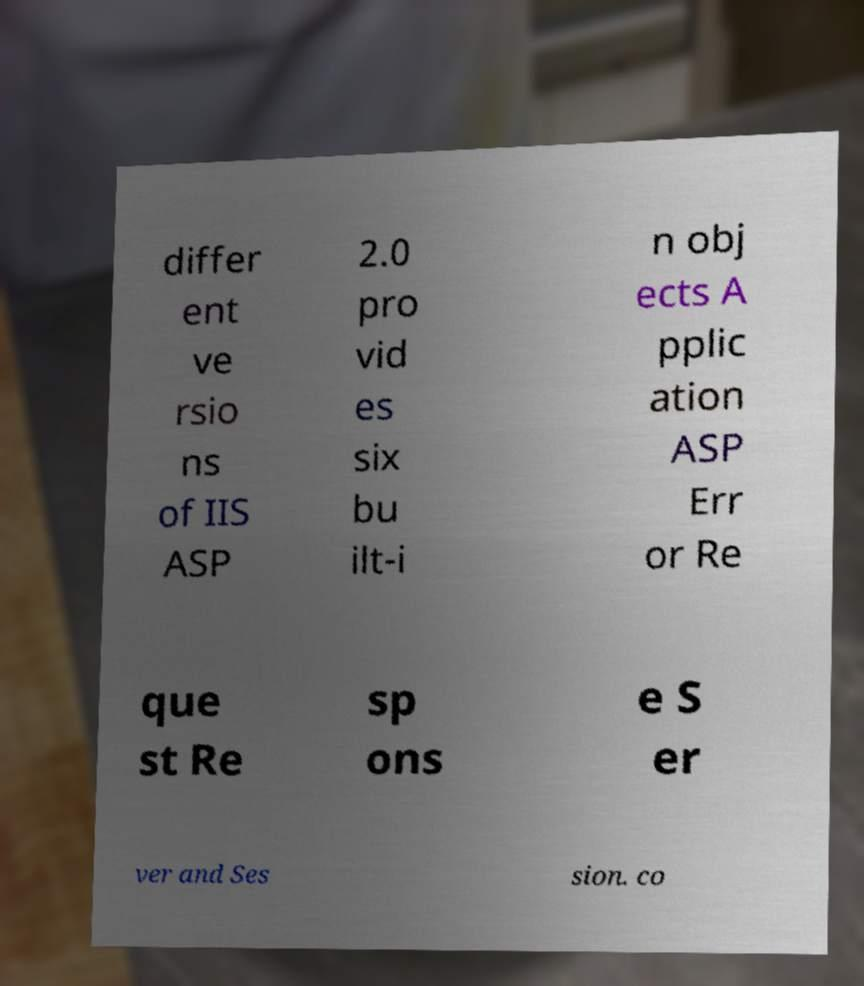For documentation purposes, I need the text within this image transcribed. Could you provide that? differ ent ve rsio ns of IIS ASP 2.0 pro vid es six bu ilt-i n obj ects A pplic ation ASP Err or Re que st Re sp ons e S er ver and Ses sion. co 